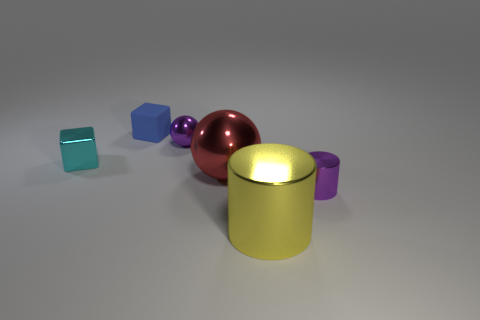There is a small object that is the same shape as the big red object; what is it made of?
Provide a succinct answer. Metal. How many things are the same size as the yellow cylinder?
Give a very brief answer. 1. There is a big object that is made of the same material as the large red sphere; what is its color?
Offer a terse response. Yellow. Are there fewer tiny purple balls than large objects?
Offer a terse response. Yes. How many gray objects are either small spheres or large shiny cubes?
Provide a succinct answer. 0. How many purple metal things are in front of the large red object and on the left side of the purple cylinder?
Ensure brevity in your answer.  0. Does the yellow thing have the same material as the red thing?
Ensure brevity in your answer.  Yes. There is a cyan shiny object that is the same size as the blue block; what shape is it?
Ensure brevity in your answer.  Cube. Are there more blocks than small metallic things?
Your response must be concise. No. What is the object that is to the left of the purple metal ball and behind the small cyan object made of?
Provide a succinct answer. Rubber. 